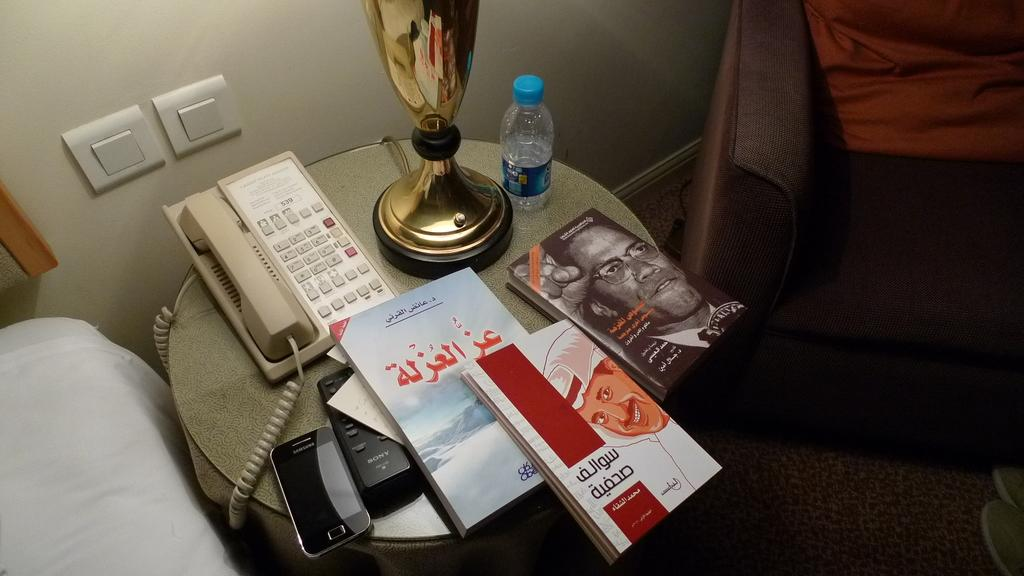<image>
Give a short and clear explanation of the subsequent image. A bedside table holds a Sony remote control and a Samsung phone. 